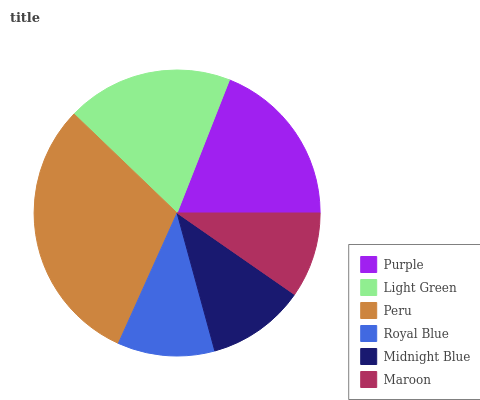Is Maroon the minimum?
Answer yes or no. Yes. Is Peru the maximum?
Answer yes or no. Yes. Is Light Green the minimum?
Answer yes or no. No. Is Light Green the maximum?
Answer yes or no. No. Is Purple greater than Light Green?
Answer yes or no. Yes. Is Light Green less than Purple?
Answer yes or no. Yes. Is Light Green greater than Purple?
Answer yes or no. No. Is Purple less than Light Green?
Answer yes or no. No. Is Light Green the high median?
Answer yes or no. Yes. Is Midnight Blue the low median?
Answer yes or no. Yes. Is Maroon the high median?
Answer yes or no. No. Is Maroon the low median?
Answer yes or no. No. 